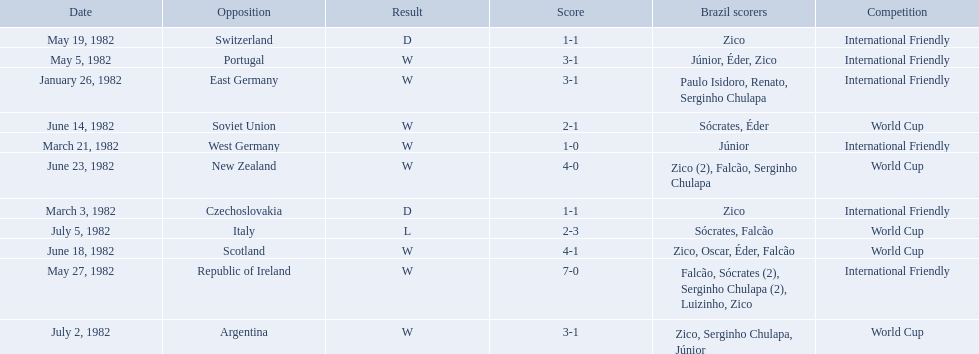How many goals did brazil score against the soviet union? 2-1. How many goals did brazil score against portugal? 3-1. Did brazil score more goals against portugal or the soviet union? Portugal. What are the dates? January 26, 1982, March 3, 1982, March 21, 1982, May 5, 1982, May 19, 1982, May 27, 1982, June 14, 1982, June 18, 1982, June 23, 1982, July 2, 1982, July 5, 1982. And which date is listed first? January 26, 1982. 